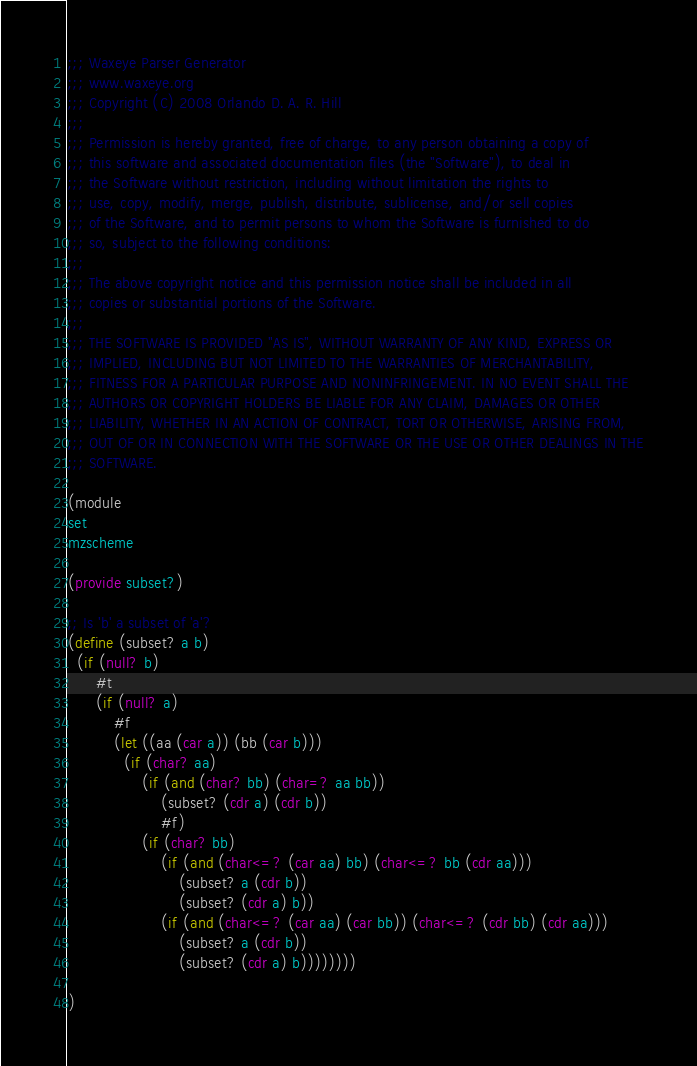Convert code to text. <code><loc_0><loc_0><loc_500><loc_500><_Scheme_>;;; Waxeye Parser Generator
;;; www.waxeye.org
;;; Copyright (C) 2008 Orlando D. A. R. Hill
;;;
;;; Permission is hereby granted, free of charge, to any person obtaining a copy of
;;; this software and associated documentation files (the "Software"), to deal in
;;; the Software without restriction, including without limitation the rights to
;;; use, copy, modify, merge, publish, distribute, sublicense, and/or sell copies
;;; of the Software, and to permit persons to whom the Software is furnished to do
;;; so, subject to the following conditions:
;;;
;;; The above copyright notice and this permission notice shall be included in all
;;; copies or substantial portions of the Software.
;;;
;;; THE SOFTWARE IS PROVIDED "AS IS", WITHOUT WARRANTY OF ANY KIND, EXPRESS OR
;;; IMPLIED, INCLUDING BUT NOT LIMITED TO THE WARRANTIES OF MERCHANTABILITY,
;;; FITNESS FOR A PARTICULAR PURPOSE AND NONINFRINGEMENT. IN NO EVENT SHALL THE
;;; AUTHORS OR COPYRIGHT HOLDERS BE LIABLE FOR ANY CLAIM, DAMAGES OR OTHER
;;; LIABILITY, WHETHER IN AN ACTION OF CONTRACT, TORT OR OTHERWISE, ARISING FROM,
;;; OUT OF OR IN CONNECTION WITH THE SOFTWARE OR THE USE OR OTHER DEALINGS IN THE
;;; SOFTWARE.

(module
set
mzscheme

(provide subset?)

;; Is 'b' a subset of 'a'?
(define (subset? a b)
  (if (null? b)
      #t
      (if (null? a)
          #f
          (let ((aa (car a)) (bb (car b)))
            (if (char? aa)
                (if (and (char? bb) (char=? aa bb))
                    (subset? (cdr a) (cdr b))
                    #f)
                (if (char? bb)
                    (if (and (char<=? (car aa) bb) (char<=? bb (cdr aa)))
                        (subset? a (cdr b))
                        (subset? (cdr a) b))
                    (if (and (char<=? (car aa) (car bb)) (char<=? (cdr bb) (cdr aa)))
                        (subset? a (cdr b))
                        (subset? (cdr a) b))))))))

)
</code> 